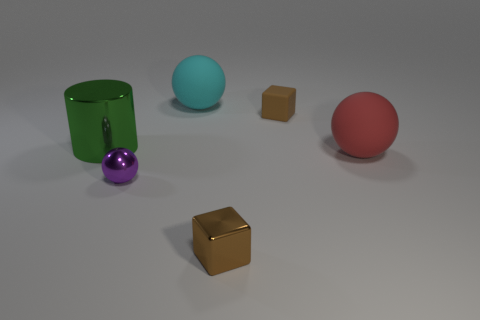Subtract all shiny spheres. How many spheres are left? 2 Add 3 red rubber spheres. How many objects exist? 9 Subtract all purple balls. How many balls are left? 2 Subtract 1 spheres. How many spheres are left? 2 Subtract all green cubes. How many brown balls are left? 0 Subtract 0 purple blocks. How many objects are left? 6 Subtract all blocks. How many objects are left? 4 Subtract all cyan balls. Subtract all blue cubes. How many balls are left? 2 Subtract all big red matte objects. Subtract all yellow metal spheres. How many objects are left? 5 Add 4 large red objects. How many large red objects are left? 5 